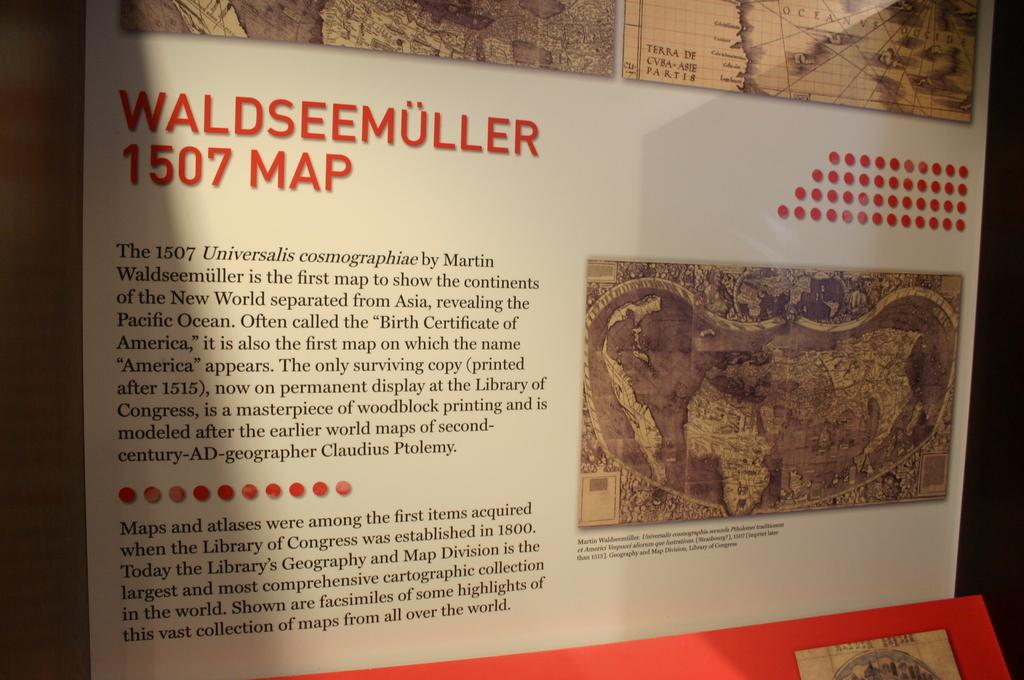<image>
Provide a brief description of the given image. 1507 map by Martin Waldseemuller is the first map to show the continents of the new world. 